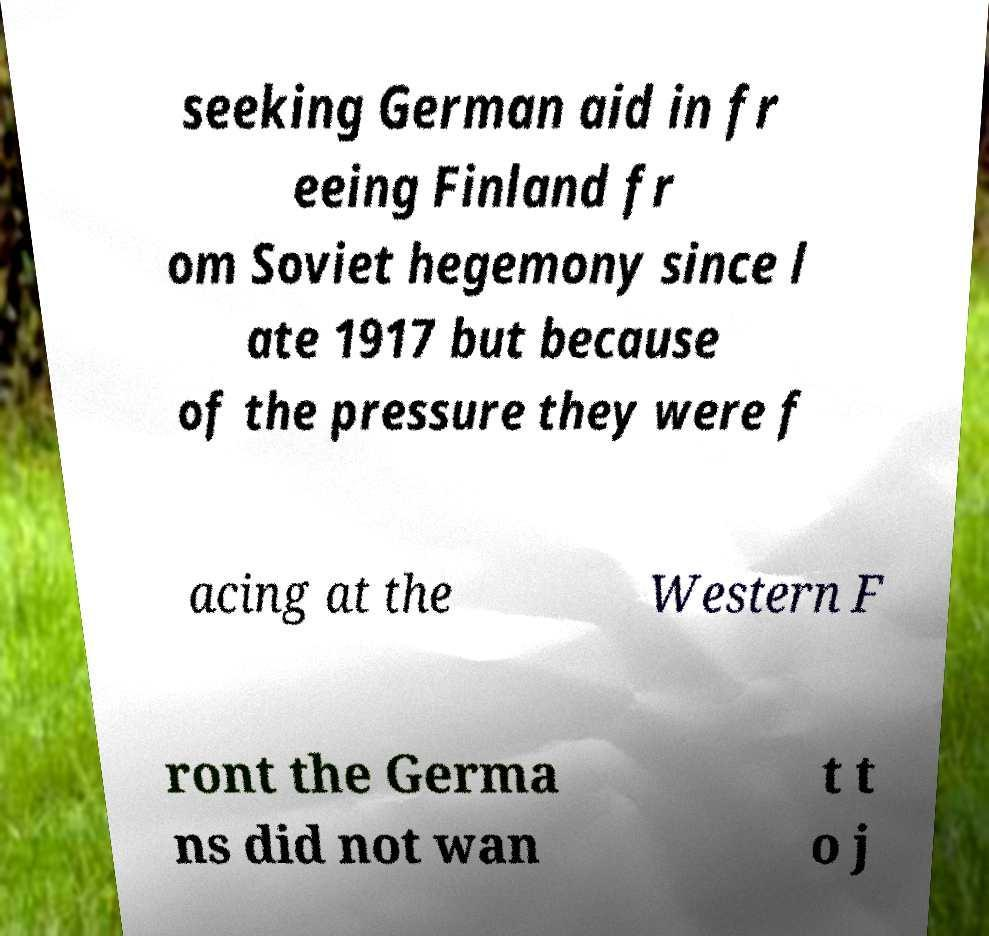For documentation purposes, I need the text within this image transcribed. Could you provide that? seeking German aid in fr eeing Finland fr om Soviet hegemony since l ate 1917 but because of the pressure they were f acing at the Western F ront the Germa ns did not wan t t o j 